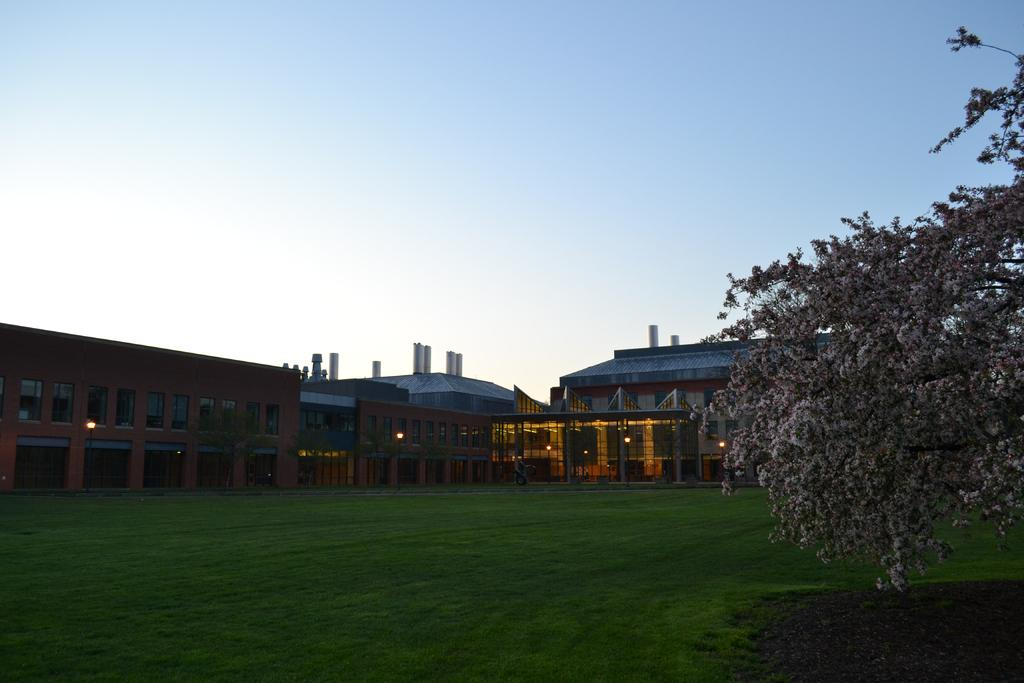What type of vegetation is on the right side of the image? There is a tree on the right side of the image. What is in the foreground of the image? There is grass in the foreground of the image. What type of structures can be seen in the middle of the image? There are buildings in the middle of the image. What is visible at the top of the image? The sky is visible at the top of the image. Can you tell me how many people are smiling in the image? There are no people present in the image, so it is not possible to determine how many are smiling. What type of guide is depicted in the image? There is no guide present in the image. 